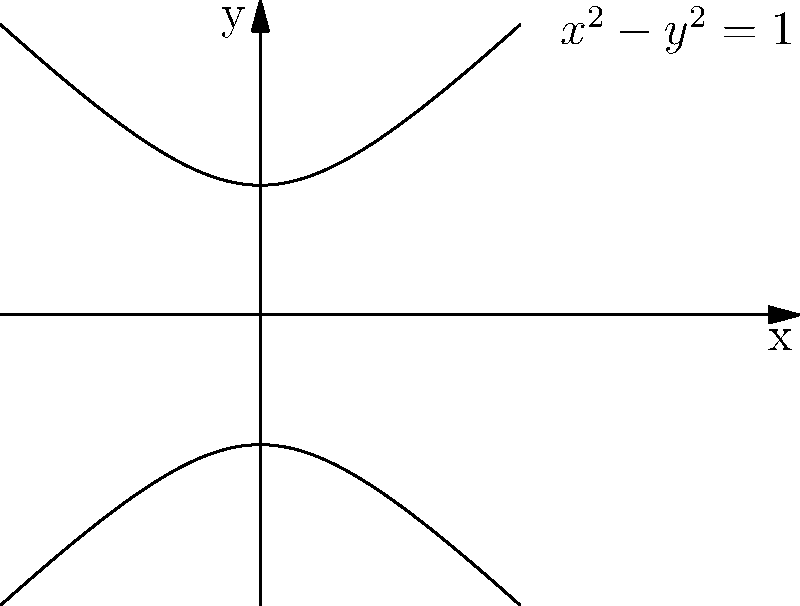As a financial analyst for Money magazine, you're researching investment trends represented by mathematical models. You encounter a graph that resembles a hyperbola. The general equation of this conic section is given by $Ax^2 + By^2 + Cx + Dy + E = 0$, where $A$ and $B$ have opposite signs and $C = D = 0$. What specific type of conic section does this equation represent, and how does it relate to the graph shown? To identify the type of conic section, let's analyze the given information step-by-step:

1) The general equation is $Ax^2 + By^2 + Cx + Dy + E = 0$.

2) We're told that $A$ and $B$ have opposite signs, and $C = D = 0$.

3) This simplifies our equation to: $Ax^2 + By^2 + E = 0$.

4) When $A$ and $B$ have opposite signs, it's a key characteristic of a hyperbola.

5) The standard form of a hyperbola equation is:
   $$\frac{x^2}{a^2} - \frac{y^2}{b^2} = 1$$ (if centered at the origin)

6) Our equation can be rearranged to match this form:
   $$x^2 - y^2 = 1$$ (where $a = b = 1$)

7) This represents a hyperbola centered at (0,0) with vertices at (±1,0) and asymptotes $y = ±x$.

8) The graph shown matches this description, with two separate curves that approach the asymptotes $y = ±x$ as $x$ approaches infinity.

Therefore, this equation represents a hyperbola, specifically an east-west opening hyperbola (since the $x^2$ term is positive).
Answer: East-west opening hyperbola 